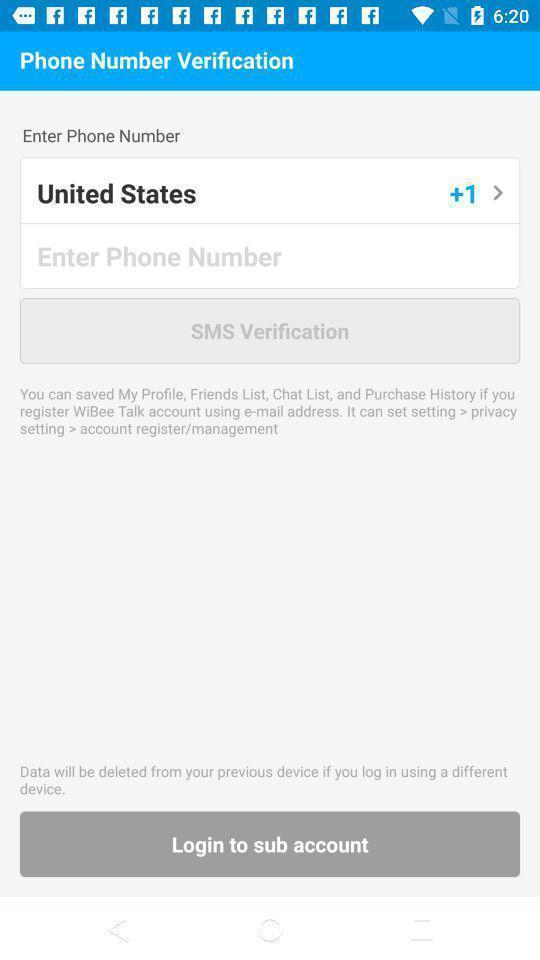Summarize the main components in this picture. Verification page for a shopping app. 